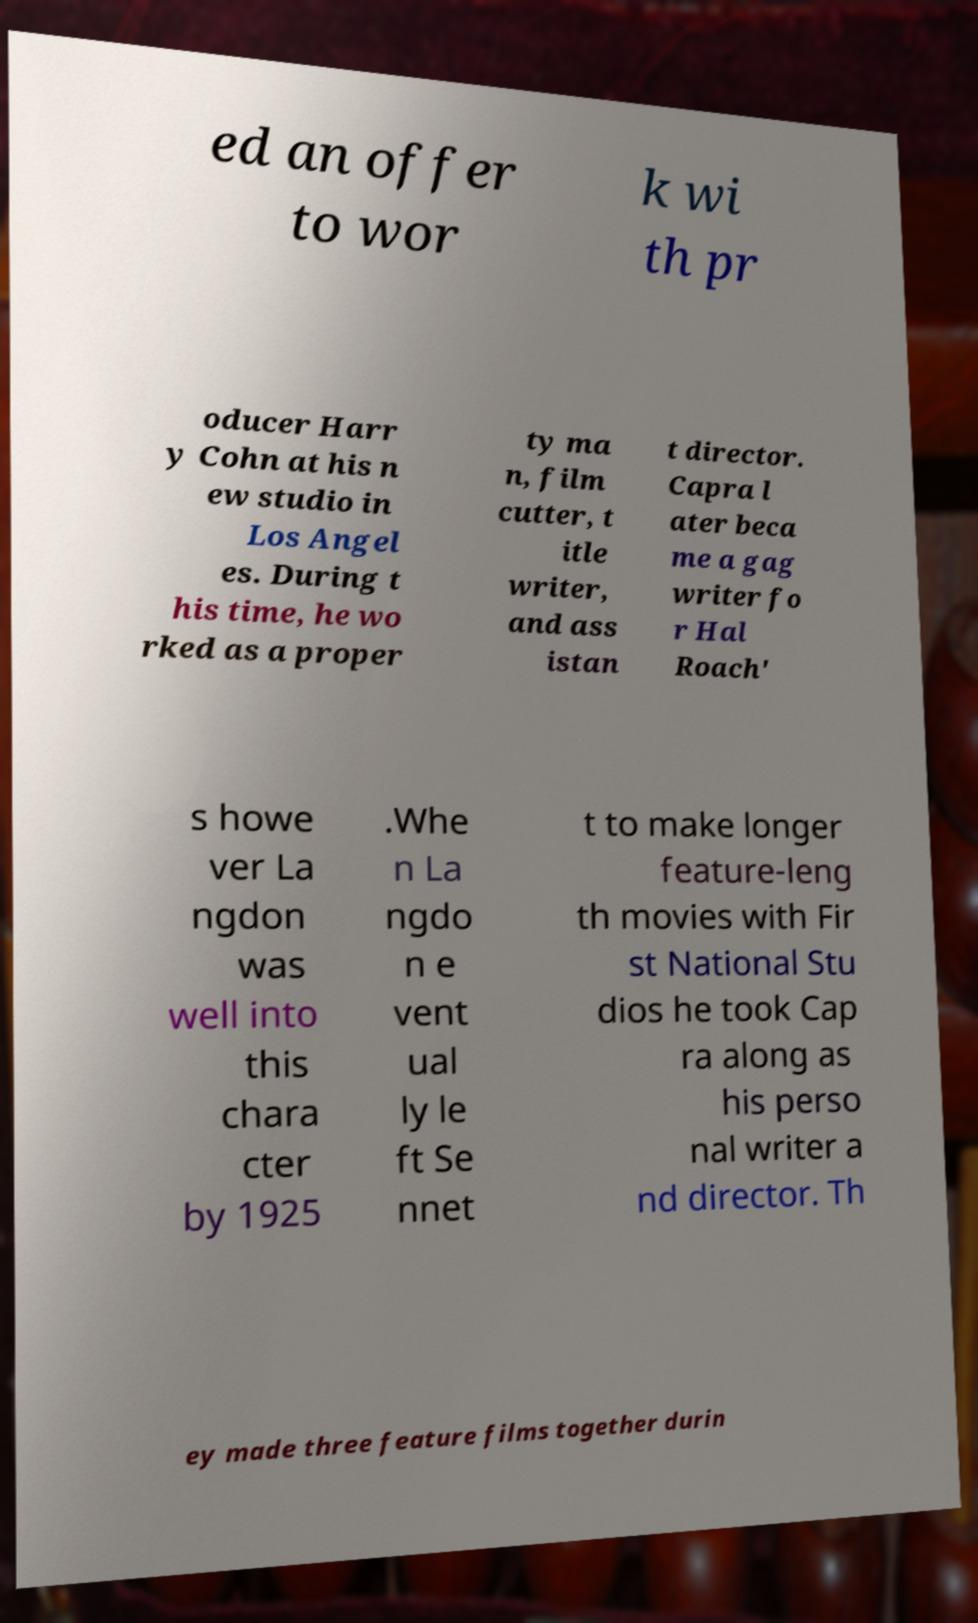Could you extract and type out the text from this image? ed an offer to wor k wi th pr oducer Harr y Cohn at his n ew studio in Los Angel es. During t his time, he wo rked as a proper ty ma n, film cutter, t itle writer, and ass istan t director. Capra l ater beca me a gag writer fo r Hal Roach' s howe ver La ngdon was well into this chara cter by 1925 .Whe n La ngdo n e vent ual ly le ft Se nnet t to make longer feature-leng th movies with Fir st National Stu dios he took Cap ra along as his perso nal writer a nd director. Th ey made three feature films together durin 